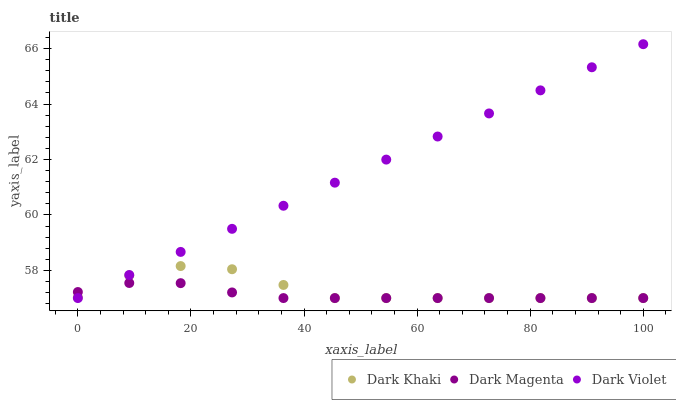Does Dark Magenta have the minimum area under the curve?
Answer yes or no. Yes. Does Dark Violet have the maximum area under the curve?
Answer yes or no. Yes. Does Dark Violet have the minimum area under the curve?
Answer yes or no. No. Does Dark Magenta have the maximum area under the curve?
Answer yes or no. No. Is Dark Violet the smoothest?
Answer yes or no. Yes. Is Dark Khaki the roughest?
Answer yes or no. Yes. Is Dark Magenta the smoothest?
Answer yes or no. No. Is Dark Magenta the roughest?
Answer yes or no. No. Does Dark Khaki have the lowest value?
Answer yes or no. Yes. Does Dark Violet have the highest value?
Answer yes or no. Yes. Does Dark Magenta have the highest value?
Answer yes or no. No. Does Dark Khaki intersect Dark Violet?
Answer yes or no. Yes. Is Dark Khaki less than Dark Violet?
Answer yes or no. No. Is Dark Khaki greater than Dark Violet?
Answer yes or no. No. 